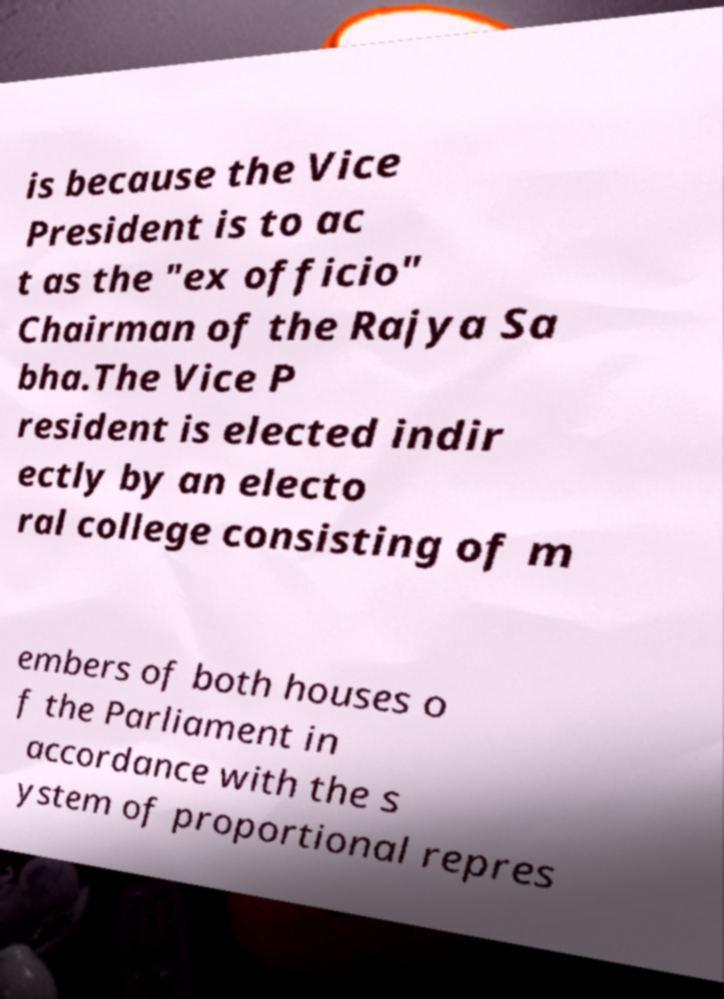I need the written content from this picture converted into text. Can you do that? is because the Vice President is to ac t as the "ex officio" Chairman of the Rajya Sa bha.The Vice P resident is elected indir ectly by an electo ral college consisting of m embers of both houses o f the Parliament in accordance with the s ystem of proportional repres 